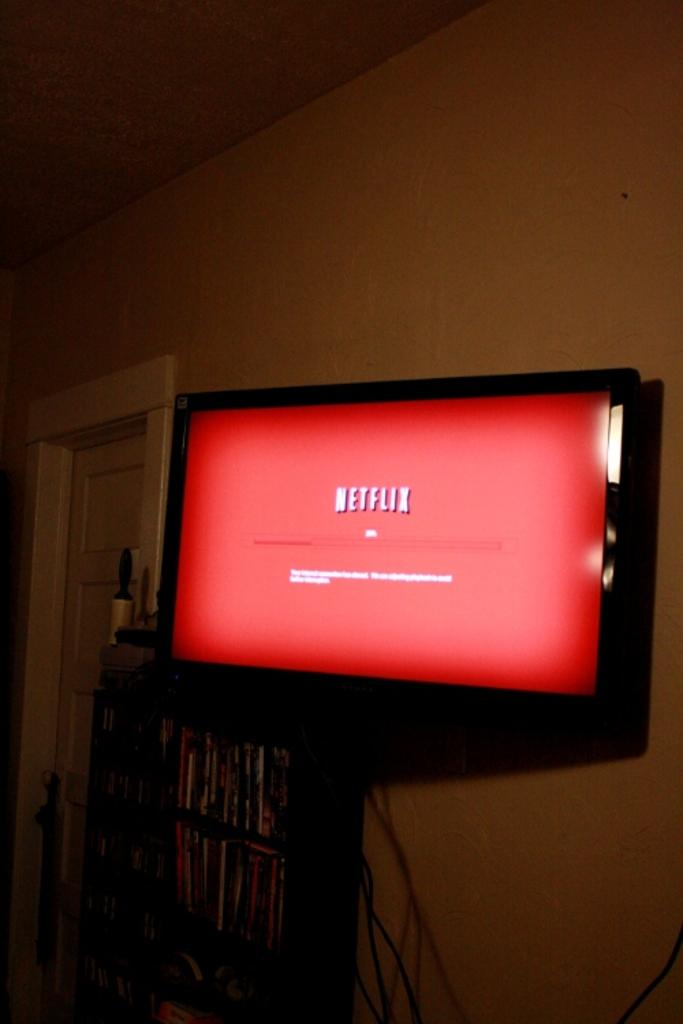Provide a one-sentence caption for the provided image. A TV mounted to the wall with the Netflix starting screen. 